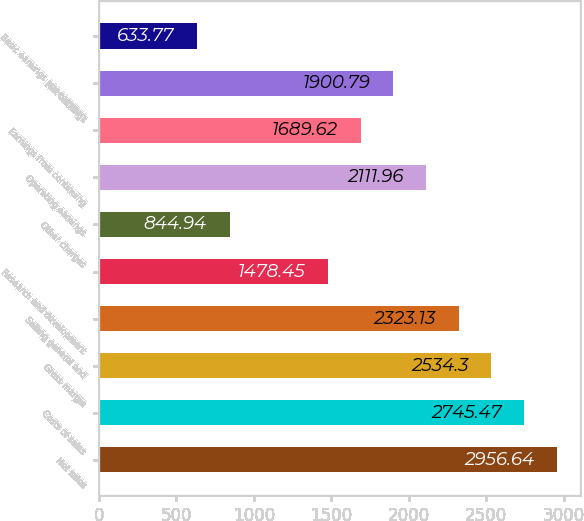Convert chart to OTSL. <chart><loc_0><loc_0><loc_500><loc_500><bar_chart><fcel>Net sales<fcel>Costs of sales<fcel>Gross margin<fcel>Selling general and<fcel>Research and development<fcel>Other charges<fcel>Operating earnings<fcel>Earnings from continuing<fcel>Net earnings<fcel>Basic earnings per common<nl><fcel>2956.64<fcel>2745.47<fcel>2534.3<fcel>2323.13<fcel>1478.45<fcel>844.94<fcel>2111.96<fcel>1689.62<fcel>1900.79<fcel>633.77<nl></chart> 